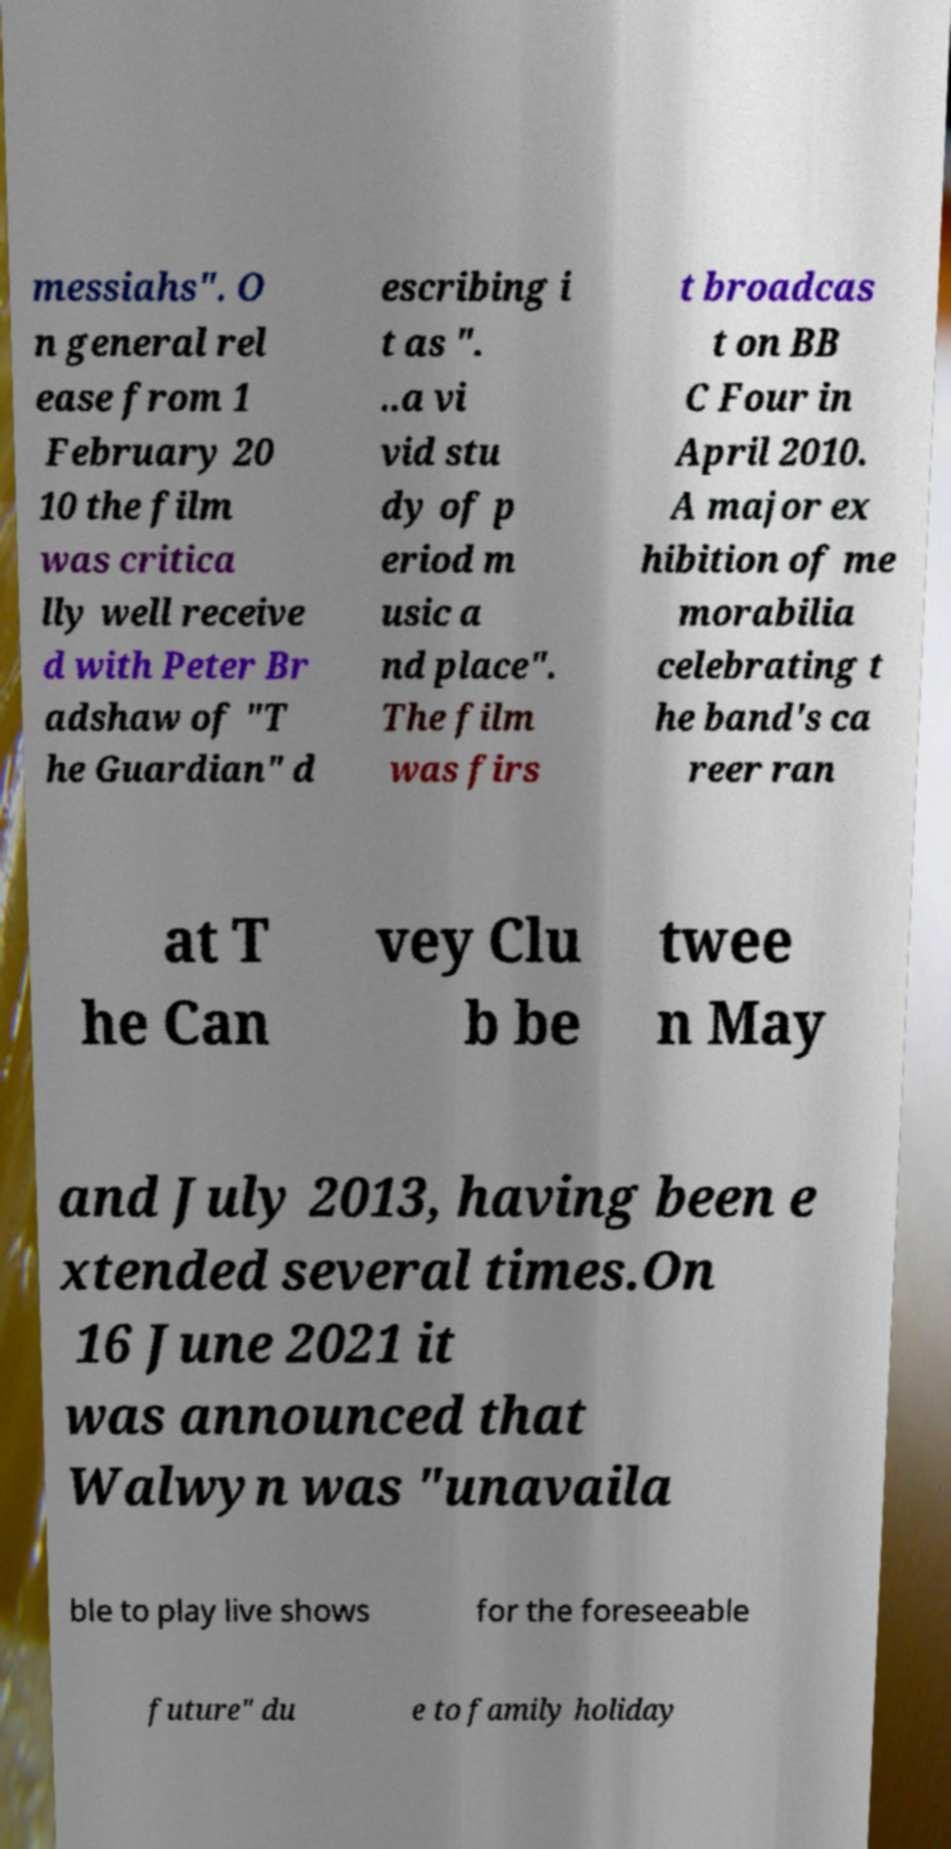Could you extract and type out the text from this image? messiahs". O n general rel ease from 1 February 20 10 the film was critica lly well receive d with Peter Br adshaw of "T he Guardian" d escribing i t as ". ..a vi vid stu dy of p eriod m usic a nd place". The film was firs t broadcas t on BB C Four in April 2010. A major ex hibition of me morabilia celebrating t he band's ca reer ran at T he Can vey Clu b be twee n May and July 2013, having been e xtended several times.On 16 June 2021 it was announced that Walwyn was "unavaila ble to play live shows for the foreseeable future" du e to family holiday 